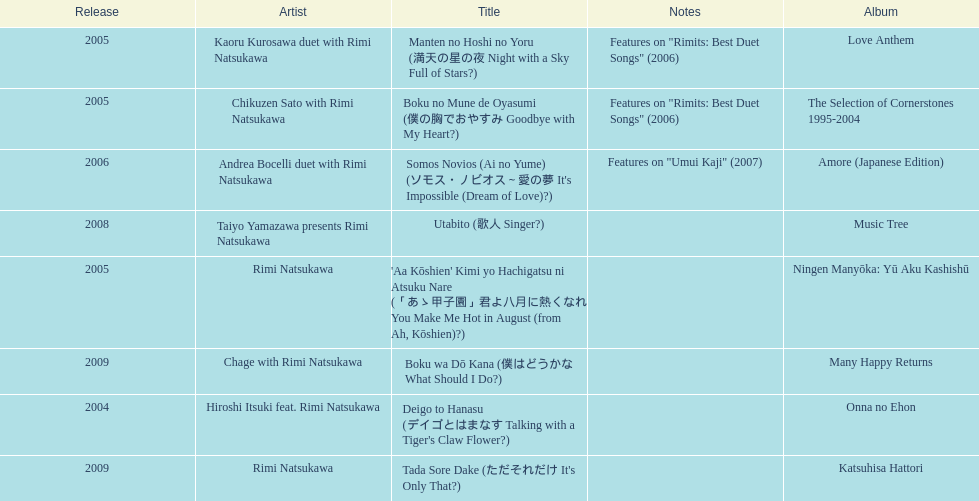How many other appearance did this artist make in 2005? 3. 